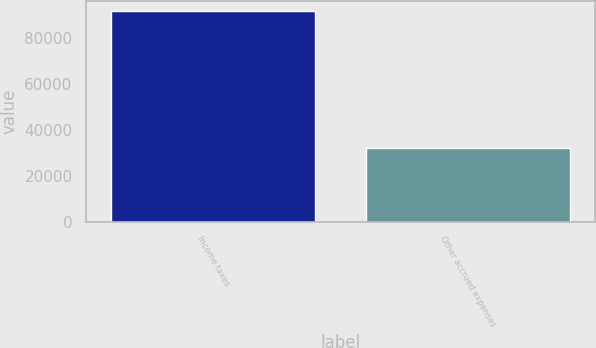Convert chart. <chart><loc_0><loc_0><loc_500><loc_500><bar_chart><fcel>Income taxes<fcel>Other accrued expenses<nl><fcel>91771<fcel>32280<nl></chart> 